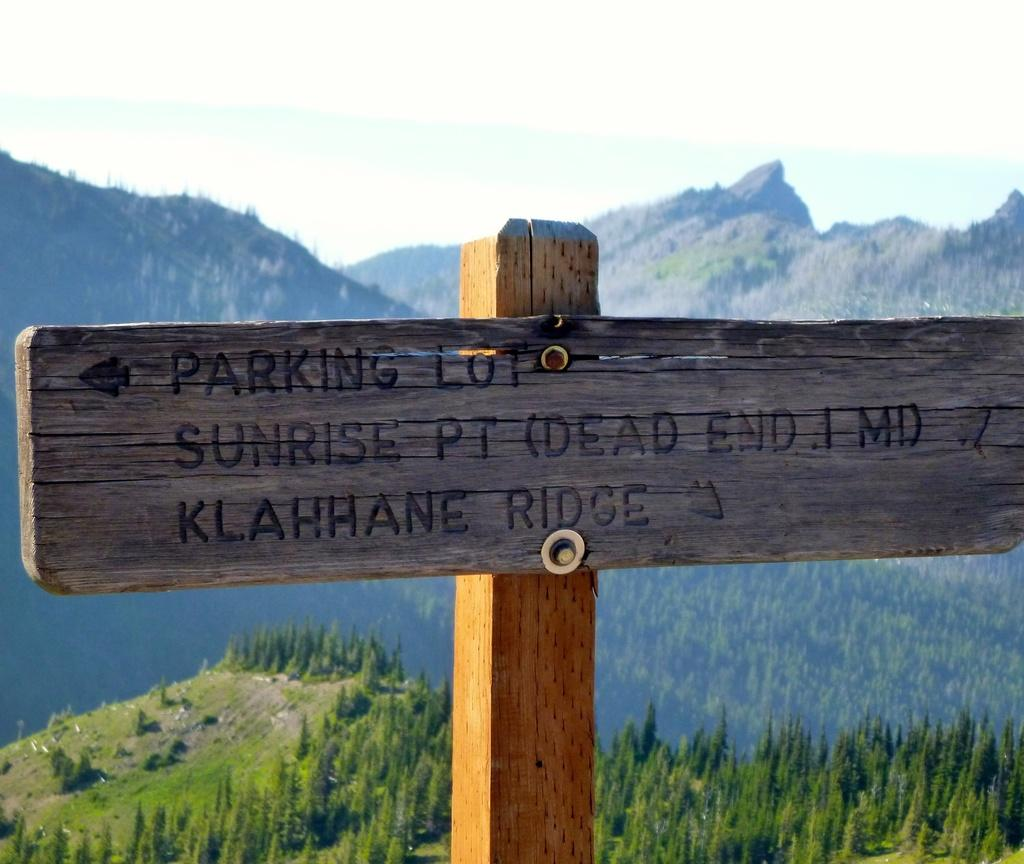What is the main object in the middle of the image? There is a wooden pole in the middle of the image. What is attached to the wooden pole? There is a sign board on the wooden pole. What can be seen in the background of the image? Hills, trees, and clouds are visible in the background of the image. What part of the sky is visible in the image? The sky is visible at the top of the image, and clouds are present within it. What type of voyage is being discussed in the meeting depicted in the image? There is no meeting or voyage depicted in the image; it features a wooden pole with a sign board and a background with hills, trees, clouds, and the sky. 